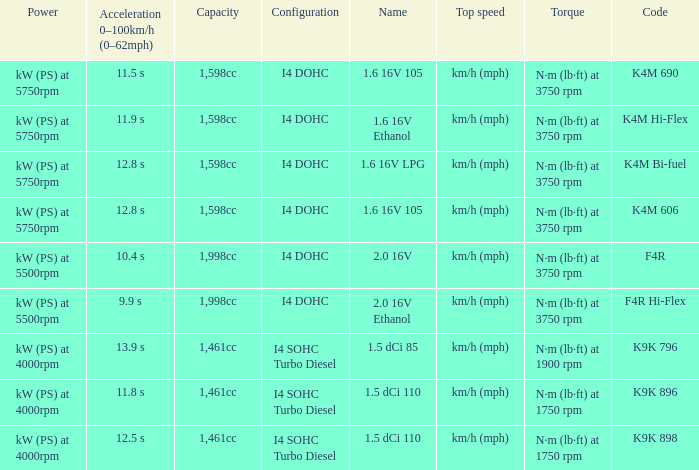What is the code of 1.5 dci 110, which has a capacity of 1,461cc? K9K 896, K9K 898. 